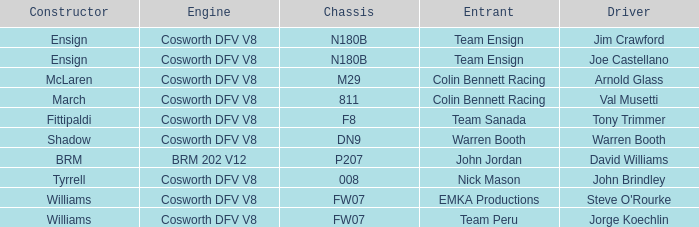What chassis does the shadow built car use? DN9. I'm looking to parse the entire table for insights. Could you assist me with that? {'header': ['Constructor', 'Engine', 'Chassis', 'Entrant', 'Driver'], 'rows': [['Ensign', 'Cosworth DFV V8', 'N180B', 'Team Ensign', 'Jim Crawford'], ['Ensign', 'Cosworth DFV V8', 'N180B', 'Team Ensign', 'Joe Castellano'], ['McLaren', 'Cosworth DFV V8', 'M29', 'Colin Bennett Racing', 'Arnold Glass'], ['March', 'Cosworth DFV V8', '811', 'Colin Bennett Racing', 'Val Musetti'], ['Fittipaldi', 'Cosworth DFV V8', 'F8', 'Team Sanada', 'Tony Trimmer'], ['Shadow', 'Cosworth DFV V8', 'DN9', 'Warren Booth', 'Warren Booth'], ['BRM', 'BRM 202 V12', 'P207', 'John Jordan', 'David Williams'], ['Tyrrell', 'Cosworth DFV V8', '008', 'Nick Mason', 'John Brindley'], ['Williams', 'Cosworth DFV V8', 'FW07', 'EMKA Productions', "Steve O'Rourke"], ['Williams', 'Cosworth DFV V8', 'FW07', 'Team Peru', 'Jorge Koechlin']]} 